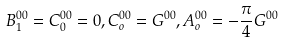<formula> <loc_0><loc_0><loc_500><loc_500>B _ { 1 } ^ { 0 0 } = C _ { 0 } ^ { 0 0 } = 0 , C _ { o } ^ { 0 0 } = G ^ { 0 0 } , A _ { o } ^ { 0 0 } = - \frac { \pi } { 4 } G ^ { 0 0 }</formula> 